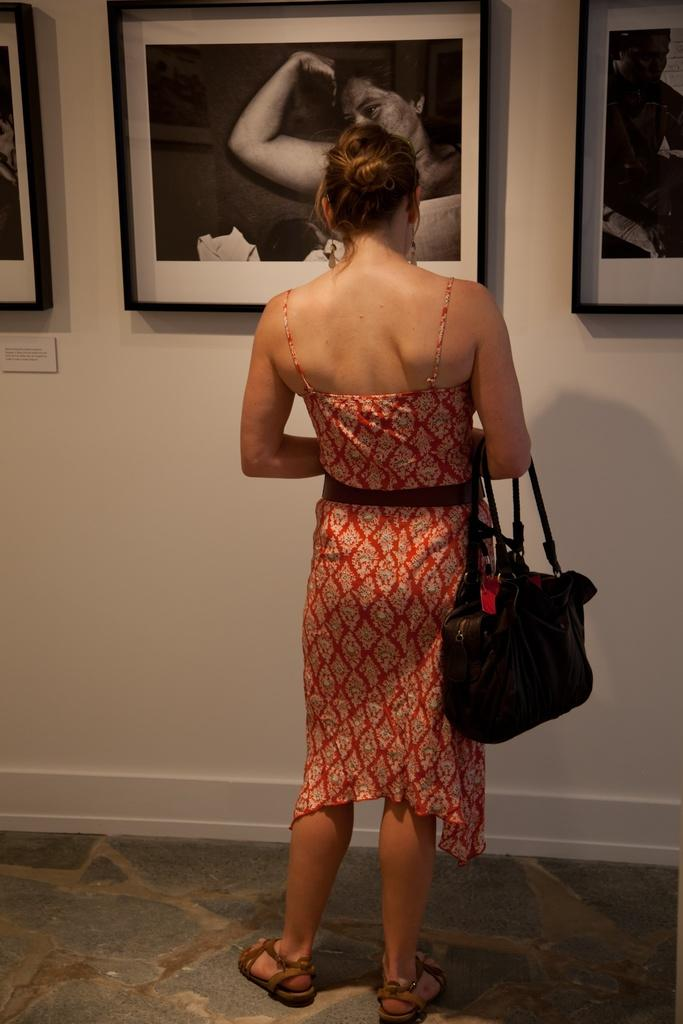Who is present in the image? There is a lady in the image. What is the lady holding in the image? The lady is holding a handbag. Where is the lady standing in the image? The lady is standing in front of a wall. What can be seen on the wall in the image? There are photo frames on the wall. What type of mint is growing on the wall in the image? There is no mint growing on the wall in the image; it only features photo frames. 